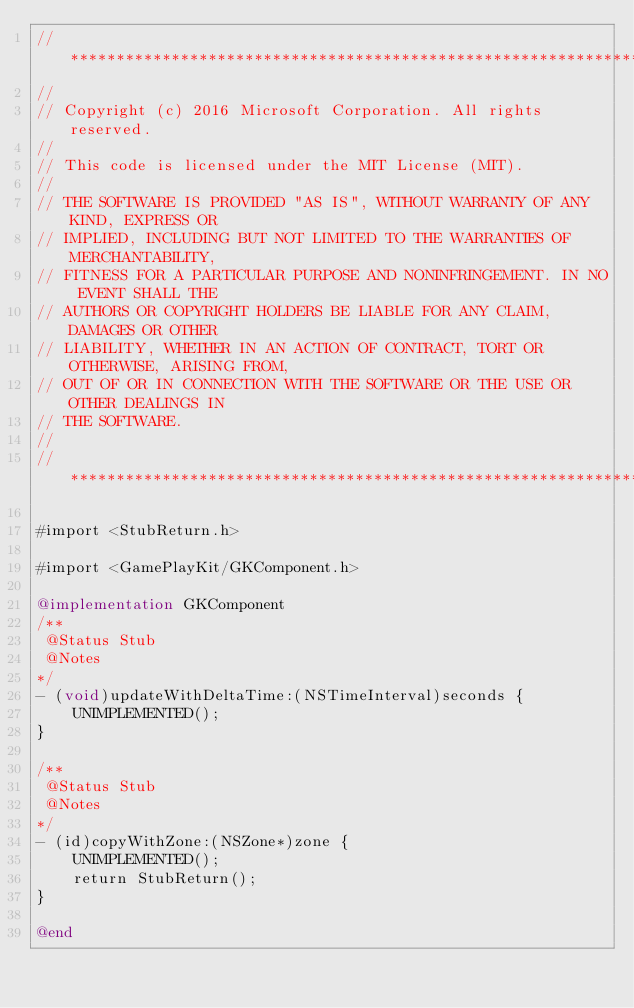<code> <loc_0><loc_0><loc_500><loc_500><_ObjectiveC_>//******************************************************************************
//
// Copyright (c) 2016 Microsoft Corporation. All rights reserved.
//
// This code is licensed under the MIT License (MIT).
//
// THE SOFTWARE IS PROVIDED "AS IS", WITHOUT WARRANTY OF ANY KIND, EXPRESS OR
// IMPLIED, INCLUDING BUT NOT LIMITED TO THE WARRANTIES OF MERCHANTABILITY,
// FITNESS FOR A PARTICULAR PURPOSE AND NONINFRINGEMENT. IN NO EVENT SHALL THE
// AUTHORS OR COPYRIGHT HOLDERS BE LIABLE FOR ANY CLAIM, DAMAGES OR OTHER
// LIABILITY, WHETHER IN AN ACTION OF CONTRACT, TORT OR OTHERWISE, ARISING FROM,
// OUT OF OR IN CONNECTION WITH THE SOFTWARE OR THE USE OR OTHER DEALINGS IN
// THE SOFTWARE.
//
//******************************************************************************

#import <StubReturn.h>

#import <GamePlayKit/GKComponent.h>

@implementation GKComponent
/**
 @Status Stub
 @Notes
*/
- (void)updateWithDeltaTime:(NSTimeInterval)seconds {
    UNIMPLEMENTED();
}

/**
 @Status Stub
 @Notes
*/
- (id)copyWithZone:(NSZone*)zone {
    UNIMPLEMENTED();
    return StubReturn();
}

@end
</code> 